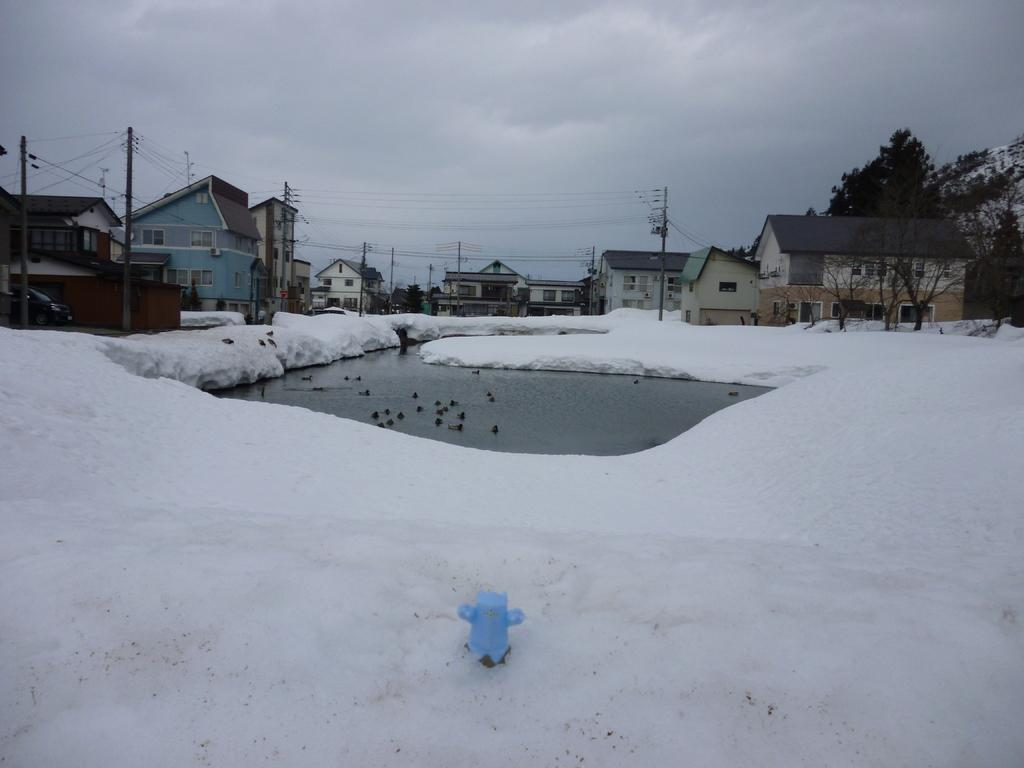What is the main feature in the center of the image? There is water in the center of the image. What can be seen at the bottom of the image? There is snow at the bottom of the image. What structures are visible in the background of the image? There are buildings and poles in the background of the image. What type of vegetation is present in the background of the image? There are trees in the background of the image. What else can be seen in the background of the image? There is snow and the sky visible in the background of the image. What are the weather conditions like in the image? The presence of snow and clouds in the background suggests a cold and possibly overcast day. How many family members are visible in the image? There are no family members present in the image; it features water, snow, buildings, poles, trees, and the sky. What type of business is being conducted in the image? There is no indication of any business activity in the image. 